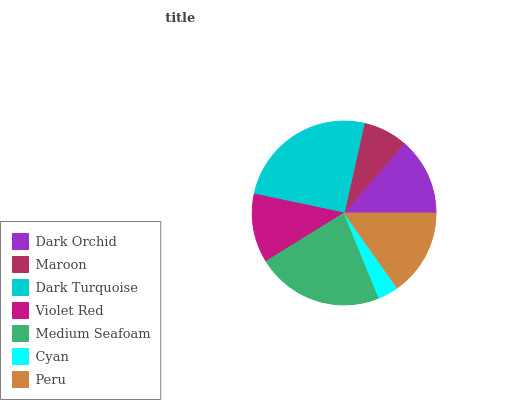Is Cyan the minimum?
Answer yes or no. Yes. Is Dark Turquoise the maximum?
Answer yes or no. Yes. Is Maroon the minimum?
Answer yes or no. No. Is Maroon the maximum?
Answer yes or no. No. Is Dark Orchid greater than Maroon?
Answer yes or no. Yes. Is Maroon less than Dark Orchid?
Answer yes or no. Yes. Is Maroon greater than Dark Orchid?
Answer yes or no. No. Is Dark Orchid less than Maroon?
Answer yes or no. No. Is Dark Orchid the high median?
Answer yes or no. Yes. Is Dark Orchid the low median?
Answer yes or no. Yes. Is Violet Red the high median?
Answer yes or no. No. Is Cyan the low median?
Answer yes or no. No. 